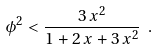<formula> <loc_0><loc_0><loc_500><loc_500>\phi ^ { 2 } < \frac { 3 \, x ^ { 2 } } { 1 + 2 \, x + 3 \, x ^ { 2 } } \ .</formula> 